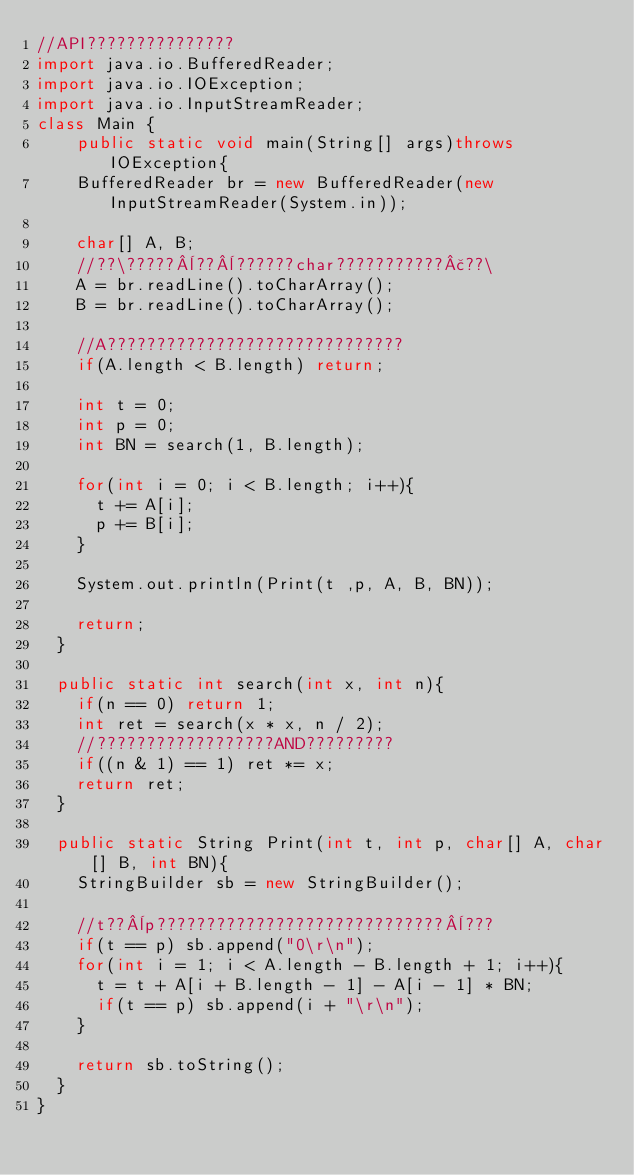<code> <loc_0><loc_0><loc_500><loc_500><_Java_>//API???????????????
import java.io.BufferedReader;
import java.io.IOException;
import java.io.InputStreamReader;
class Main {
  	public static void main(String[] args)throws IOException{
		BufferedReader br = new BufferedReader(new InputStreamReader(System.in));

		char[] A, B;
		//??\?????¨??¨??????char???????????£??\
		A = br.readLine().toCharArray();
		B = br.readLine().toCharArray();

		//A??????????????????????????????
		if(A.length < B.length) return;

		int t = 0;
		int p = 0;
		int BN = search(1, B.length);

		for(int i = 0; i < B.length; i++){
			t += A[i];
			p += B[i];
		}

		System.out.println(Print(t ,p, A, B, BN));

		return;
	}

	public static int search(int x, int n){
		if(n == 0) return 1;
		int ret = search(x * x, n / 2);
		//??????????????????AND?????????
		if((n & 1) == 1) ret *= x;
		return ret;
	}

	public static String Print(int t, int p, char[] A, char[] B, int BN){
		StringBuilder sb = new StringBuilder();

		//t??¨p?????????????????????????????¨???
		if(t == p) sb.append("0\r\n");
		for(int i = 1; i < A.length - B.length + 1; i++){
			t = t + A[i + B.length - 1] - A[i - 1] * BN;
			if(t == p) sb.append(i + "\r\n");
		}

		return sb.toString();
	}
}</code> 